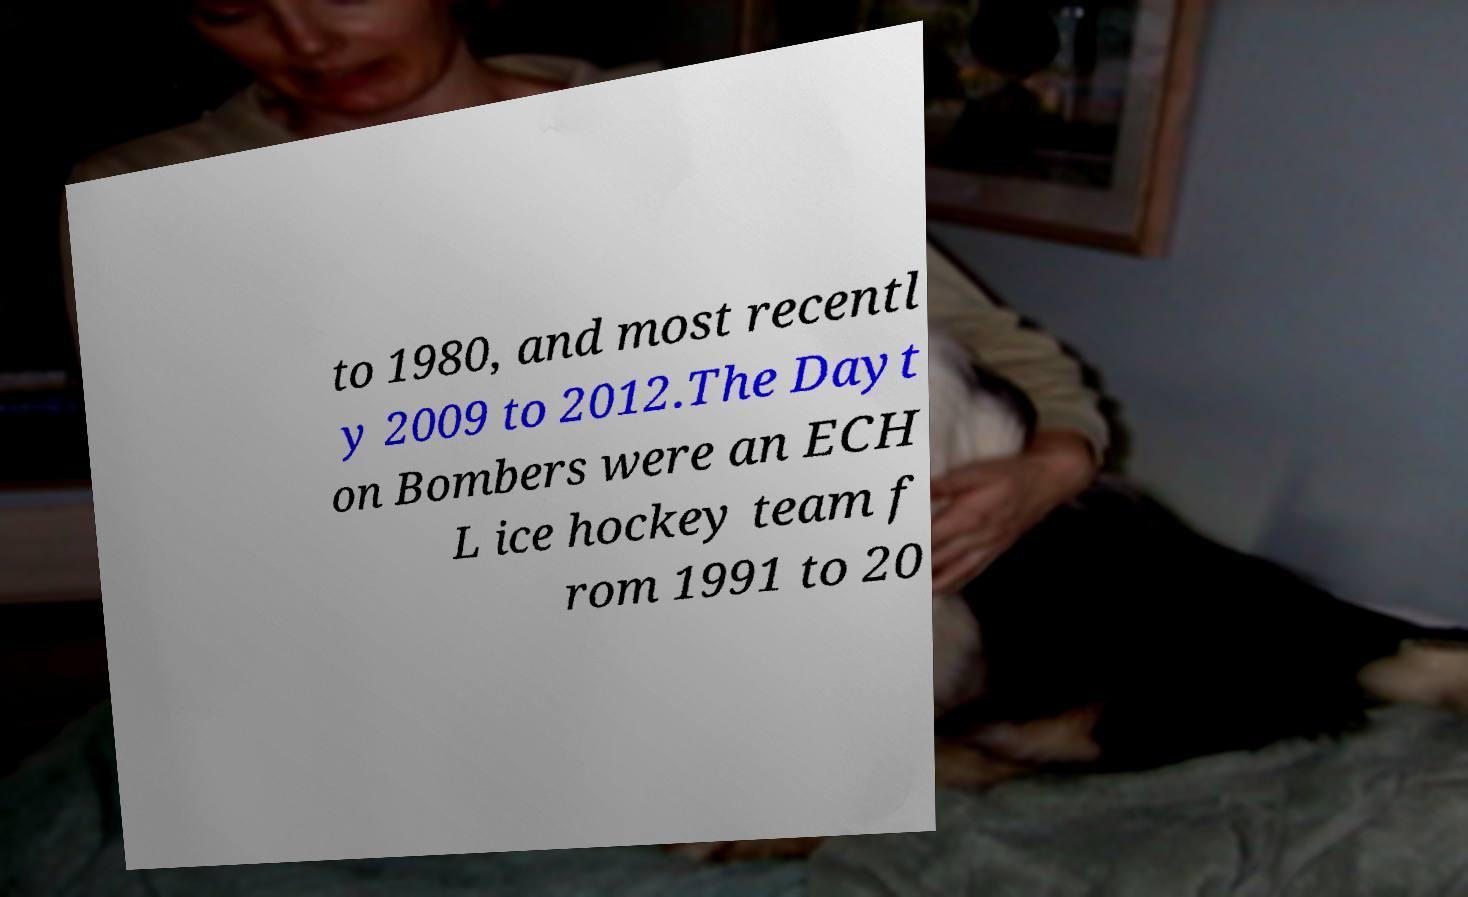Can you accurately transcribe the text from the provided image for me? to 1980, and most recentl y 2009 to 2012.The Dayt on Bombers were an ECH L ice hockey team f rom 1991 to 20 